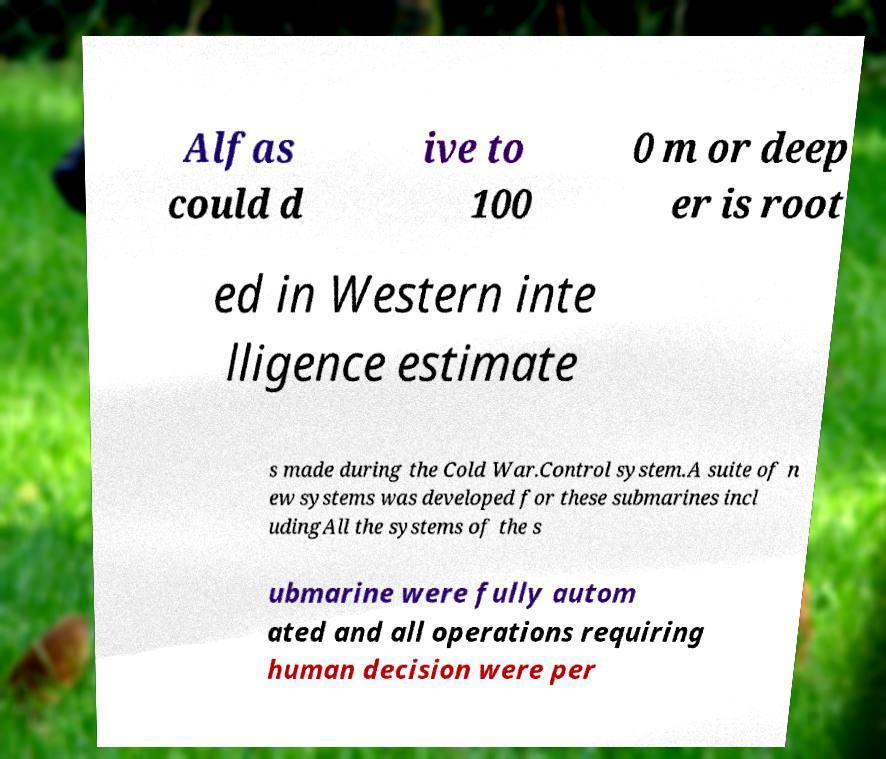For documentation purposes, I need the text within this image transcribed. Could you provide that? Alfas could d ive to 100 0 m or deep er is root ed in Western inte lligence estimate s made during the Cold War.Control system.A suite of n ew systems was developed for these submarines incl udingAll the systems of the s ubmarine were fully autom ated and all operations requiring human decision were per 